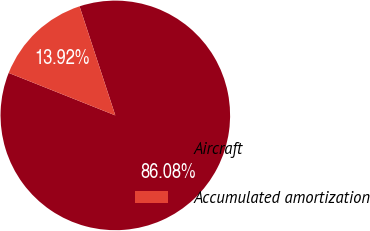<chart> <loc_0><loc_0><loc_500><loc_500><pie_chart><fcel>Aircraft<fcel>Accumulated amortization<nl><fcel>86.08%<fcel>13.92%<nl></chart> 